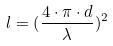Convert formula to latex. <formula><loc_0><loc_0><loc_500><loc_500>l = ( \frac { 4 \cdot \pi \cdot d } { \lambda } ) ^ { 2 }</formula> 